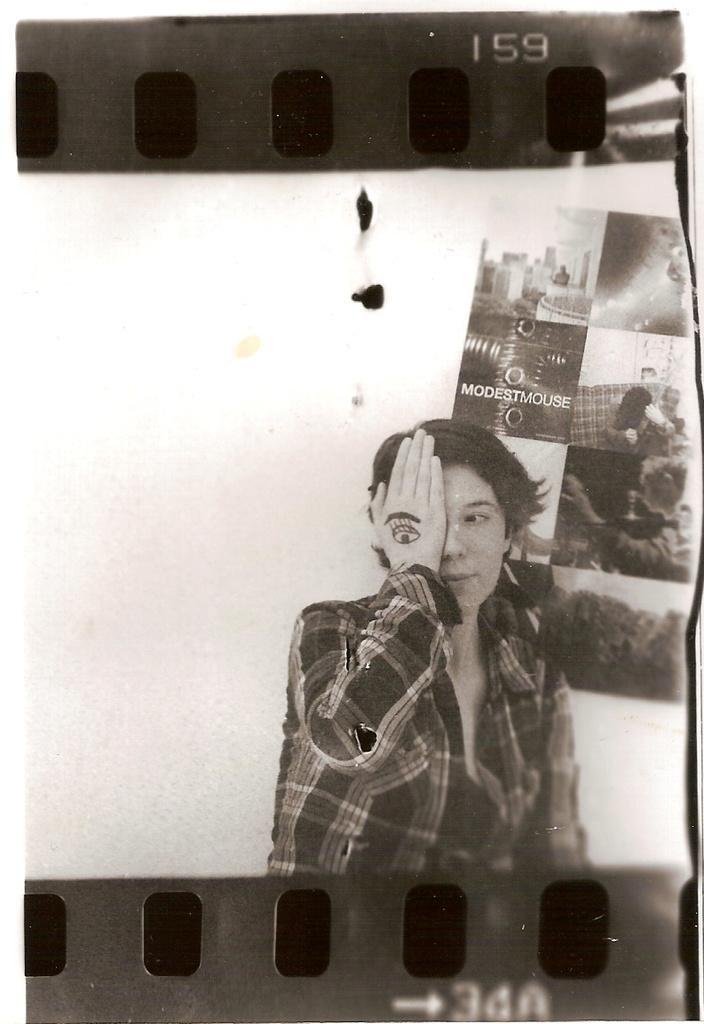Can you describe this image briefly? Here in this picture we can see the negative reel present and in that we can see a person present keeping a hand on eye and behind her we can see some posters present over there. 